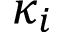<formula> <loc_0><loc_0><loc_500><loc_500>\kappa _ { i }</formula> 